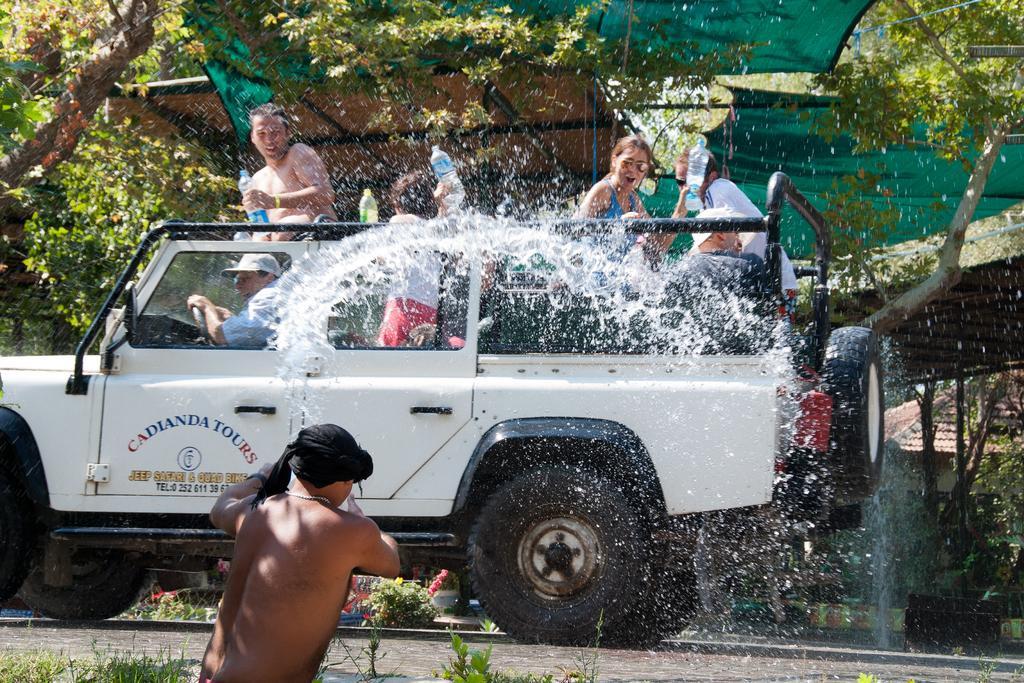In one or two sentences, can you explain what this image depicts? In this image there is a vehicle in which few persons are there. A woman is holding a bottle is wearing goggles is in the vehicle. At the bottom of the image there is a person throwing water at the vehicle is wearing a black colour cloth over his head. There are few trees at the background and at the left side there is a house. There are few plants at the bottom of the image. 